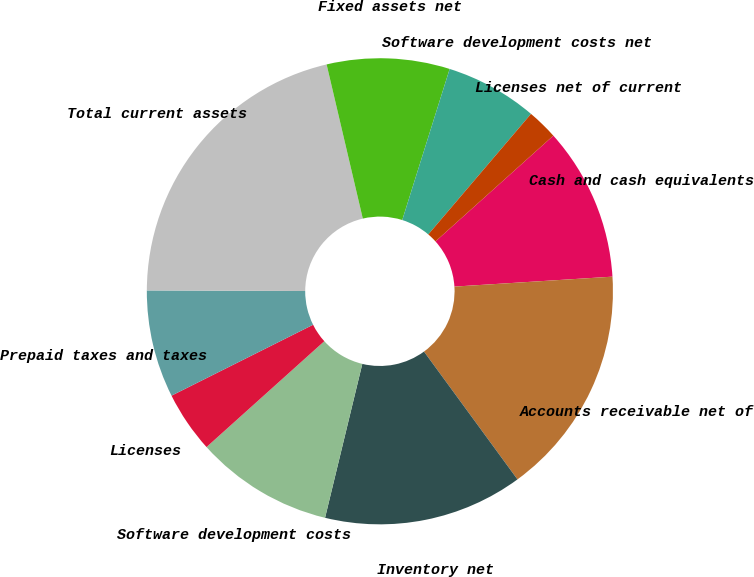Convert chart to OTSL. <chart><loc_0><loc_0><loc_500><loc_500><pie_chart><fcel>Cash and cash equivalents<fcel>Accounts receivable net of<fcel>Inventory net<fcel>Software development costs<fcel>Licenses<fcel>Prepaid taxes and taxes<fcel>Total current assets<fcel>Fixed assets net<fcel>Software development costs net<fcel>Licenses net of current<nl><fcel>10.64%<fcel>15.95%<fcel>13.83%<fcel>9.57%<fcel>4.26%<fcel>7.45%<fcel>21.27%<fcel>8.51%<fcel>6.39%<fcel>2.13%<nl></chart> 